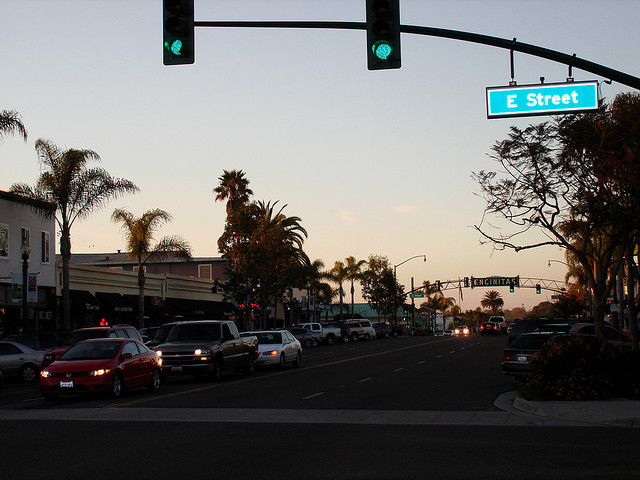<image>What store is in the background? It is ambiguous what store is in the background. It could be a clothing store, aldi, target, a mall, a coffee shop, a department store, or a gas station. What store is in the background? In the background, it can be seen a store. It is unknown which store it is. 